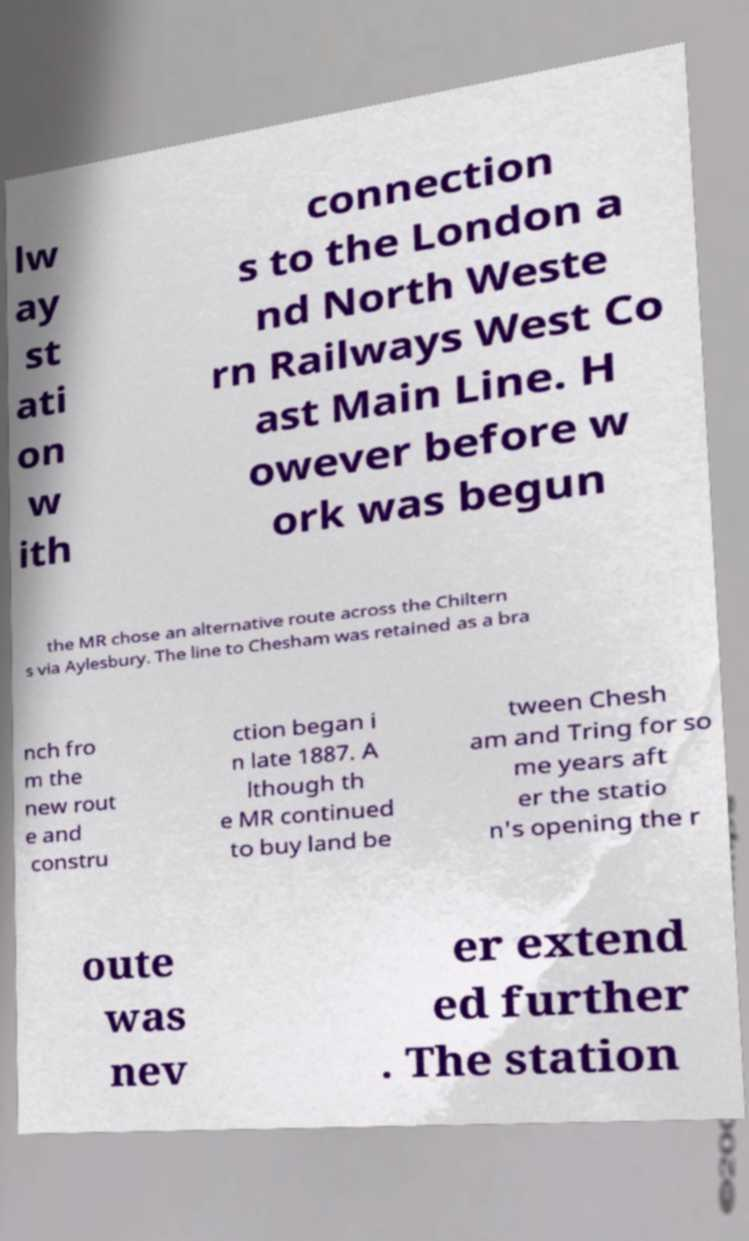Please identify and transcribe the text found in this image. lw ay st ati on w ith connection s to the London a nd North Weste rn Railways West Co ast Main Line. H owever before w ork was begun the MR chose an alternative route across the Chiltern s via Aylesbury. The line to Chesham was retained as a bra nch fro m the new rout e and constru ction began i n late 1887. A lthough th e MR continued to buy land be tween Chesh am and Tring for so me years aft er the statio n's opening the r oute was nev er extend ed further . The station 